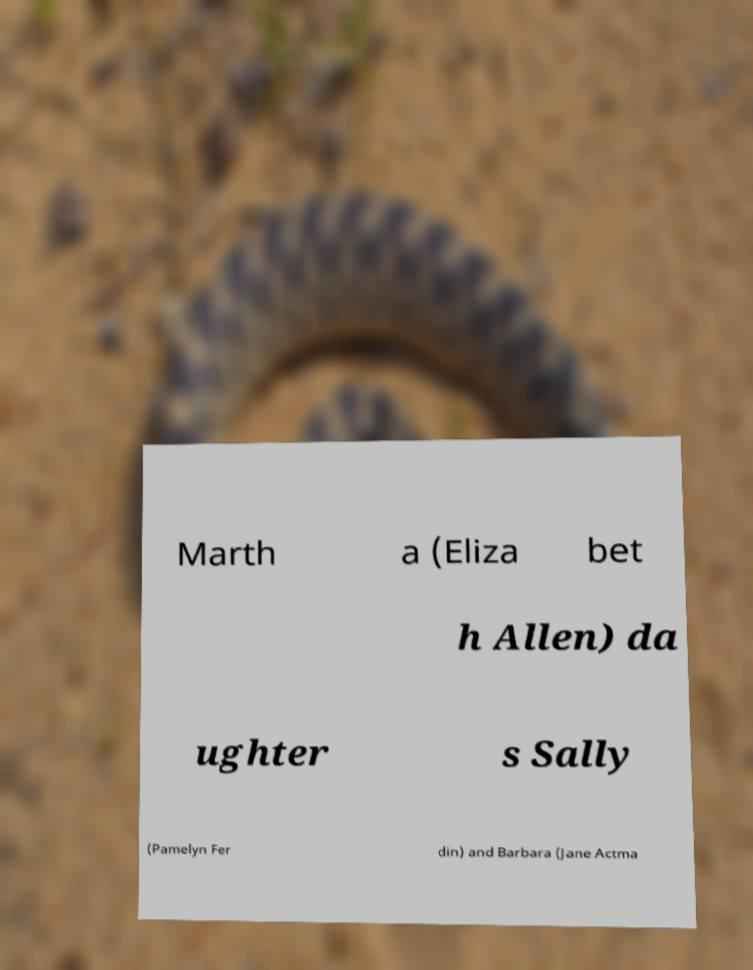There's text embedded in this image that I need extracted. Can you transcribe it verbatim? Marth a (Eliza bet h Allen) da ughter s Sally (Pamelyn Fer din) and Barbara (Jane Actma 